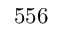Convert formula to latex. <formula><loc_0><loc_0><loc_500><loc_500>5 5 6</formula> 